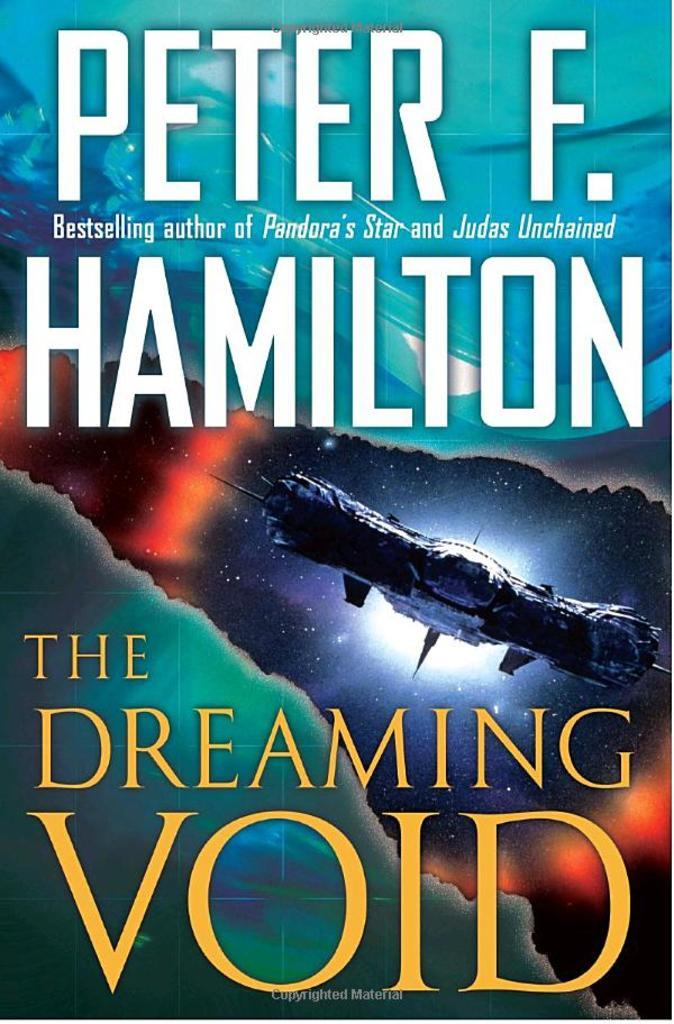<image>
Describe the image concisely. A copy of Peter F. Hamilton's book The Dreaming Void. 